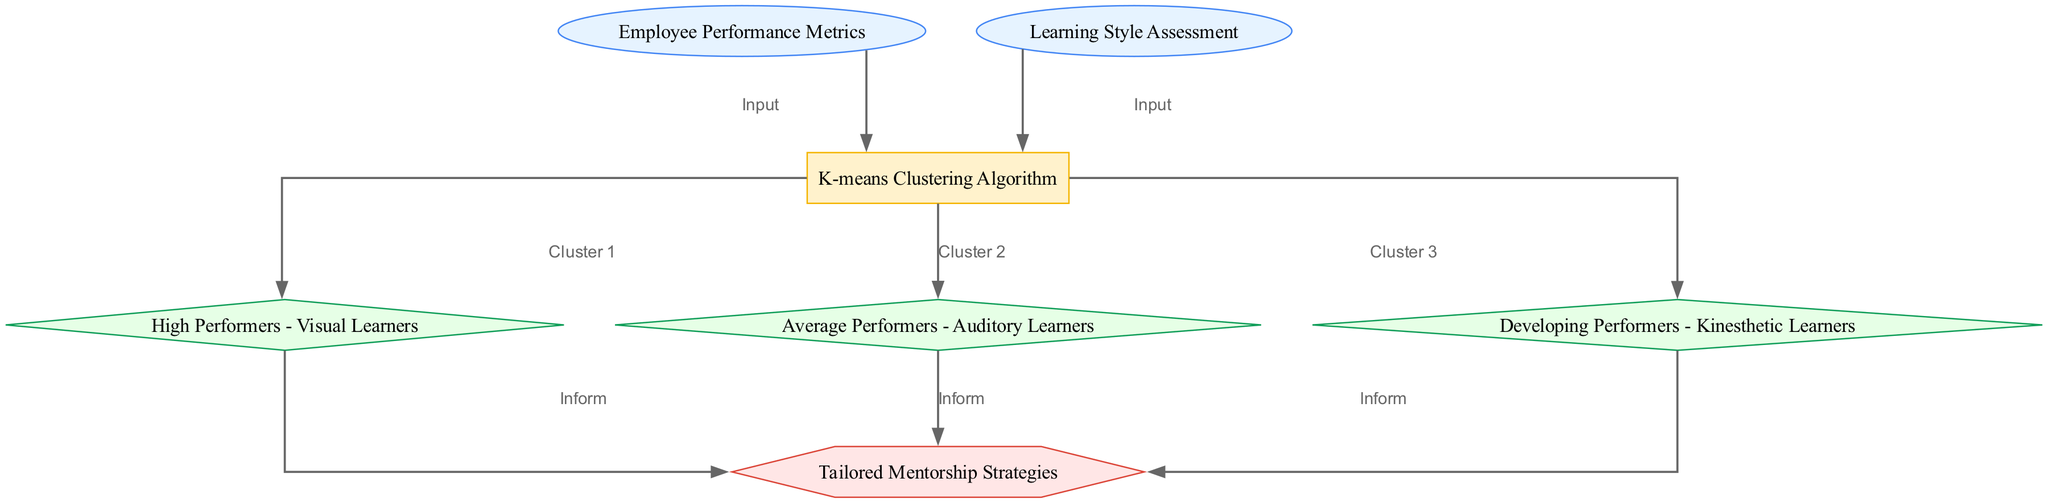What are the two input nodes in this diagram? The diagram includes "Employee Performance Metrics" as the first input node and "Learning Style Assessment" as the second input node.
Answer: Employee Performance Metrics, Learning Style Assessment How many output clusters are defined in the diagram? The diagram specifies three output clusters: "High Performers - Visual Learners," "Average Performers - Auditory Learners," and "Developing Performers - Kinesthetic Learners." Therefore, there are three output clusters.
Answer: Three What process connects the two input nodes to the output clusters? The process that connects the two input nodes to the output clusters is the "K-means Clustering Algorithm." This algorithm analyzes the inputs and creates the clusters based on the provided metrics and assessments.
Answer: K-means Clustering Algorithm Which output cluster corresponds to the highest performance and what type of learner is it associated with? The output cluster that corresponds to the highest performance is "High Performers - Visual Learners." This indicates that visual learners are categorized as high performers based on the analysis.
Answer: High Performers - Visual Learners What decision node is reached after analyzing the output clusters? The decision node reached after analyzing all the output clusters is "Tailored Mentorship Strategies." This node determines the appropriate strategies for mentoring based on the specific clusters identified.
Answer: Tailored Mentorship Strategies How many connections inform the decision node from the output clusters? The decision node "Tailored Mentorship Strategies" has three informing connections coming from each of the output clusters: high performers, average performers, and developing performers. Thus, there are three connections.
Answer: Three 